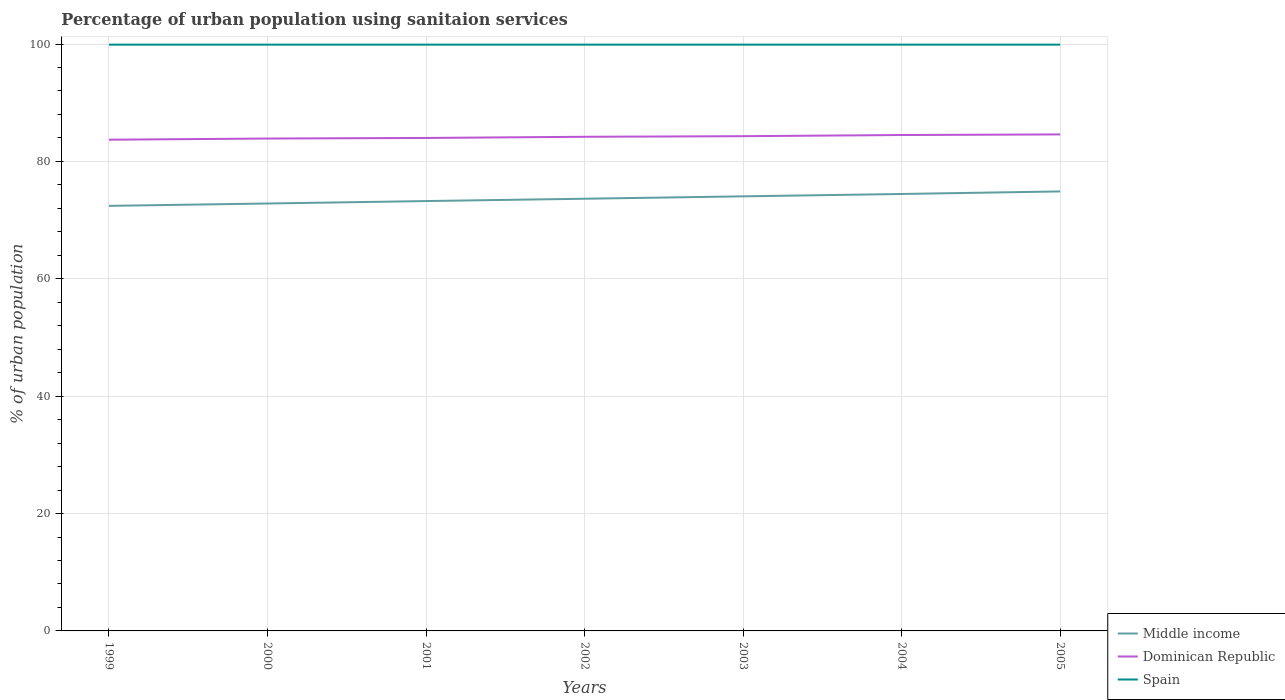Across all years, what is the maximum percentage of urban population using sanitaion services in Middle income?
Keep it short and to the point. 72.43. What is the total percentage of urban population using sanitaion services in Dominican Republic in the graph?
Ensure brevity in your answer.  -0.8. What is the difference between the highest and the lowest percentage of urban population using sanitaion services in Dominican Republic?
Your response must be concise. 4. Is the percentage of urban population using sanitaion services in Spain strictly greater than the percentage of urban population using sanitaion services in Dominican Republic over the years?
Your answer should be very brief. No. How many years are there in the graph?
Provide a succinct answer. 7. Does the graph contain grids?
Give a very brief answer. Yes. How are the legend labels stacked?
Your answer should be very brief. Vertical. What is the title of the graph?
Give a very brief answer. Percentage of urban population using sanitaion services. Does "Andorra" appear as one of the legend labels in the graph?
Your answer should be very brief. No. What is the label or title of the Y-axis?
Ensure brevity in your answer.  % of urban population. What is the % of urban population of Middle income in 1999?
Provide a succinct answer. 72.43. What is the % of urban population of Dominican Republic in 1999?
Keep it short and to the point. 83.7. What is the % of urban population in Spain in 1999?
Provide a succinct answer. 99.9. What is the % of urban population of Middle income in 2000?
Make the answer very short. 72.83. What is the % of urban population of Dominican Republic in 2000?
Provide a short and direct response. 83.9. What is the % of urban population in Spain in 2000?
Offer a very short reply. 99.9. What is the % of urban population in Middle income in 2001?
Offer a very short reply. 73.25. What is the % of urban population in Spain in 2001?
Make the answer very short. 99.9. What is the % of urban population of Middle income in 2002?
Your answer should be compact. 73.64. What is the % of urban population of Dominican Republic in 2002?
Your response must be concise. 84.2. What is the % of urban population of Spain in 2002?
Provide a succinct answer. 99.9. What is the % of urban population in Middle income in 2003?
Keep it short and to the point. 74.05. What is the % of urban population of Dominican Republic in 2003?
Offer a very short reply. 84.3. What is the % of urban population of Spain in 2003?
Offer a very short reply. 99.9. What is the % of urban population of Middle income in 2004?
Your answer should be very brief. 74.45. What is the % of urban population of Dominican Republic in 2004?
Offer a very short reply. 84.5. What is the % of urban population in Spain in 2004?
Offer a very short reply. 99.9. What is the % of urban population in Middle income in 2005?
Provide a short and direct response. 74.89. What is the % of urban population of Dominican Republic in 2005?
Give a very brief answer. 84.6. What is the % of urban population of Spain in 2005?
Give a very brief answer. 99.9. Across all years, what is the maximum % of urban population in Middle income?
Provide a succinct answer. 74.89. Across all years, what is the maximum % of urban population in Dominican Republic?
Make the answer very short. 84.6. Across all years, what is the maximum % of urban population of Spain?
Your answer should be compact. 99.9. Across all years, what is the minimum % of urban population of Middle income?
Keep it short and to the point. 72.43. Across all years, what is the minimum % of urban population of Dominican Republic?
Your answer should be compact. 83.7. Across all years, what is the minimum % of urban population in Spain?
Keep it short and to the point. 99.9. What is the total % of urban population of Middle income in the graph?
Keep it short and to the point. 515.54. What is the total % of urban population of Dominican Republic in the graph?
Your answer should be compact. 589.2. What is the total % of urban population of Spain in the graph?
Provide a short and direct response. 699.3. What is the difference between the % of urban population in Middle income in 1999 and that in 2000?
Ensure brevity in your answer.  -0.4. What is the difference between the % of urban population in Dominican Republic in 1999 and that in 2000?
Your answer should be compact. -0.2. What is the difference between the % of urban population of Middle income in 1999 and that in 2001?
Your answer should be very brief. -0.82. What is the difference between the % of urban population of Dominican Republic in 1999 and that in 2001?
Keep it short and to the point. -0.3. What is the difference between the % of urban population of Middle income in 1999 and that in 2002?
Keep it short and to the point. -1.22. What is the difference between the % of urban population of Spain in 1999 and that in 2002?
Your response must be concise. 0. What is the difference between the % of urban population in Middle income in 1999 and that in 2003?
Offer a terse response. -1.62. What is the difference between the % of urban population of Dominican Republic in 1999 and that in 2003?
Give a very brief answer. -0.6. What is the difference between the % of urban population of Middle income in 1999 and that in 2004?
Your answer should be compact. -2.02. What is the difference between the % of urban population of Dominican Republic in 1999 and that in 2004?
Provide a succinct answer. -0.8. What is the difference between the % of urban population in Middle income in 1999 and that in 2005?
Offer a very short reply. -2.46. What is the difference between the % of urban population of Middle income in 2000 and that in 2001?
Your answer should be very brief. -0.42. What is the difference between the % of urban population of Middle income in 2000 and that in 2002?
Offer a terse response. -0.81. What is the difference between the % of urban population in Dominican Republic in 2000 and that in 2002?
Your answer should be very brief. -0.3. What is the difference between the % of urban population of Middle income in 2000 and that in 2003?
Your response must be concise. -1.22. What is the difference between the % of urban population of Dominican Republic in 2000 and that in 2003?
Give a very brief answer. -0.4. What is the difference between the % of urban population in Spain in 2000 and that in 2003?
Provide a succinct answer. 0. What is the difference between the % of urban population in Middle income in 2000 and that in 2004?
Offer a terse response. -1.62. What is the difference between the % of urban population of Dominican Republic in 2000 and that in 2004?
Give a very brief answer. -0.6. What is the difference between the % of urban population in Middle income in 2000 and that in 2005?
Your response must be concise. -2.06. What is the difference between the % of urban population in Dominican Republic in 2000 and that in 2005?
Provide a succinct answer. -0.7. What is the difference between the % of urban population of Middle income in 2001 and that in 2002?
Offer a terse response. -0.4. What is the difference between the % of urban population in Spain in 2001 and that in 2002?
Offer a terse response. 0. What is the difference between the % of urban population in Middle income in 2001 and that in 2003?
Give a very brief answer. -0.8. What is the difference between the % of urban population of Middle income in 2001 and that in 2004?
Make the answer very short. -1.21. What is the difference between the % of urban population of Middle income in 2001 and that in 2005?
Provide a short and direct response. -1.64. What is the difference between the % of urban population in Middle income in 2002 and that in 2003?
Offer a very short reply. -0.41. What is the difference between the % of urban population in Spain in 2002 and that in 2003?
Offer a terse response. 0. What is the difference between the % of urban population in Middle income in 2002 and that in 2004?
Provide a short and direct response. -0.81. What is the difference between the % of urban population of Middle income in 2002 and that in 2005?
Provide a short and direct response. -1.25. What is the difference between the % of urban population in Middle income in 2003 and that in 2004?
Provide a succinct answer. -0.4. What is the difference between the % of urban population of Dominican Republic in 2003 and that in 2004?
Offer a very short reply. -0.2. What is the difference between the % of urban population in Spain in 2003 and that in 2004?
Your response must be concise. 0. What is the difference between the % of urban population in Middle income in 2003 and that in 2005?
Offer a very short reply. -0.84. What is the difference between the % of urban population of Dominican Republic in 2003 and that in 2005?
Keep it short and to the point. -0.3. What is the difference between the % of urban population in Spain in 2003 and that in 2005?
Give a very brief answer. 0. What is the difference between the % of urban population in Middle income in 2004 and that in 2005?
Your response must be concise. -0.44. What is the difference between the % of urban population of Middle income in 1999 and the % of urban population of Dominican Republic in 2000?
Your answer should be very brief. -11.47. What is the difference between the % of urban population in Middle income in 1999 and the % of urban population in Spain in 2000?
Provide a short and direct response. -27.47. What is the difference between the % of urban population in Dominican Republic in 1999 and the % of urban population in Spain in 2000?
Provide a succinct answer. -16.2. What is the difference between the % of urban population in Middle income in 1999 and the % of urban population in Dominican Republic in 2001?
Your answer should be very brief. -11.57. What is the difference between the % of urban population of Middle income in 1999 and the % of urban population of Spain in 2001?
Make the answer very short. -27.47. What is the difference between the % of urban population of Dominican Republic in 1999 and the % of urban population of Spain in 2001?
Give a very brief answer. -16.2. What is the difference between the % of urban population in Middle income in 1999 and the % of urban population in Dominican Republic in 2002?
Ensure brevity in your answer.  -11.77. What is the difference between the % of urban population in Middle income in 1999 and the % of urban population in Spain in 2002?
Provide a succinct answer. -27.47. What is the difference between the % of urban population in Dominican Republic in 1999 and the % of urban population in Spain in 2002?
Provide a succinct answer. -16.2. What is the difference between the % of urban population in Middle income in 1999 and the % of urban population in Dominican Republic in 2003?
Make the answer very short. -11.87. What is the difference between the % of urban population of Middle income in 1999 and the % of urban population of Spain in 2003?
Offer a terse response. -27.47. What is the difference between the % of urban population of Dominican Republic in 1999 and the % of urban population of Spain in 2003?
Provide a succinct answer. -16.2. What is the difference between the % of urban population of Middle income in 1999 and the % of urban population of Dominican Republic in 2004?
Offer a very short reply. -12.07. What is the difference between the % of urban population of Middle income in 1999 and the % of urban population of Spain in 2004?
Offer a terse response. -27.47. What is the difference between the % of urban population of Dominican Republic in 1999 and the % of urban population of Spain in 2004?
Provide a succinct answer. -16.2. What is the difference between the % of urban population in Middle income in 1999 and the % of urban population in Dominican Republic in 2005?
Provide a short and direct response. -12.17. What is the difference between the % of urban population of Middle income in 1999 and the % of urban population of Spain in 2005?
Your response must be concise. -27.47. What is the difference between the % of urban population in Dominican Republic in 1999 and the % of urban population in Spain in 2005?
Offer a very short reply. -16.2. What is the difference between the % of urban population of Middle income in 2000 and the % of urban population of Dominican Republic in 2001?
Your answer should be very brief. -11.17. What is the difference between the % of urban population in Middle income in 2000 and the % of urban population in Spain in 2001?
Provide a short and direct response. -27.07. What is the difference between the % of urban population of Middle income in 2000 and the % of urban population of Dominican Republic in 2002?
Provide a succinct answer. -11.37. What is the difference between the % of urban population in Middle income in 2000 and the % of urban population in Spain in 2002?
Provide a succinct answer. -27.07. What is the difference between the % of urban population in Dominican Republic in 2000 and the % of urban population in Spain in 2002?
Your response must be concise. -16. What is the difference between the % of urban population in Middle income in 2000 and the % of urban population in Dominican Republic in 2003?
Offer a very short reply. -11.47. What is the difference between the % of urban population in Middle income in 2000 and the % of urban population in Spain in 2003?
Ensure brevity in your answer.  -27.07. What is the difference between the % of urban population of Dominican Republic in 2000 and the % of urban population of Spain in 2003?
Provide a short and direct response. -16. What is the difference between the % of urban population in Middle income in 2000 and the % of urban population in Dominican Republic in 2004?
Keep it short and to the point. -11.67. What is the difference between the % of urban population of Middle income in 2000 and the % of urban population of Spain in 2004?
Make the answer very short. -27.07. What is the difference between the % of urban population in Dominican Republic in 2000 and the % of urban population in Spain in 2004?
Your answer should be compact. -16. What is the difference between the % of urban population in Middle income in 2000 and the % of urban population in Dominican Republic in 2005?
Your answer should be very brief. -11.77. What is the difference between the % of urban population of Middle income in 2000 and the % of urban population of Spain in 2005?
Ensure brevity in your answer.  -27.07. What is the difference between the % of urban population of Middle income in 2001 and the % of urban population of Dominican Republic in 2002?
Keep it short and to the point. -10.95. What is the difference between the % of urban population in Middle income in 2001 and the % of urban population in Spain in 2002?
Make the answer very short. -26.65. What is the difference between the % of urban population in Dominican Republic in 2001 and the % of urban population in Spain in 2002?
Offer a very short reply. -15.9. What is the difference between the % of urban population in Middle income in 2001 and the % of urban population in Dominican Republic in 2003?
Offer a very short reply. -11.05. What is the difference between the % of urban population of Middle income in 2001 and the % of urban population of Spain in 2003?
Provide a succinct answer. -26.65. What is the difference between the % of urban population in Dominican Republic in 2001 and the % of urban population in Spain in 2003?
Offer a terse response. -15.9. What is the difference between the % of urban population of Middle income in 2001 and the % of urban population of Dominican Republic in 2004?
Ensure brevity in your answer.  -11.25. What is the difference between the % of urban population of Middle income in 2001 and the % of urban population of Spain in 2004?
Offer a terse response. -26.65. What is the difference between the % of urban population of Dominican Republic in 2001 and the % of urban population of Spain in 2004?
Make the answer very short. -15.9. What is the difference between the % of urban population of Middle income in 2001 and the % of urban population of Dominican Republic in 2005?
Ensure brevity in your answer.  -11.35. What is the difference between the % of urban population of Middle income in 2001 and the % of urban population of Spain in 2005?
Give a very brief answer. -26.65. What is the difference between the % of urban population of Dominican Republic in 2001 and the % of urban population of Spain in 2005?
Keep it short and to the point. -15.9. What is the difference between the % of urban population of Middle income in 2002 and the % of urban population of Dominican Republic in 2003?
Ensure brevity in your answer.  -10.66. What is the difference between the % of urban population in Middle income in 2002 and the % of urban population in Spain in 2003?
Your answer should be compact. -26.26. What is the difference between the % of urban population of Dominican Republic in 2002 and the % of urban population of Spain in 2003?
Keep it short and to the point. -15.7. What is the difference between the % of urban population of Middle income in 2002 and the % of urban population of Dominican Republic in 2004?
Provide a succinct answer. -10.86. What is the difference between the % of urban population in Middle income in 2002 and the % of urban population in Spain in 2004?
Keep it short and to the point. -26.26. What is the difference between the % of urban population of Dominican Republic in 2002 and the % of urban population of Spain in 2004?
Offer a very short reply. -15.7. What is the difference between the % of urban population in Middle income in 2002 and the % of urban population in Dominican Republic in 2005?
Offer a very short reply. -10.96. What is the difference between the % of urban population of Middle income in 2002 and the % of urban population of Spain in 2005?
Provide a short and direct response. -26.26. What is the difference between the % of urban population in Dominican Republic in 2002 and the % of urban population in Spain in 2005?
Ensure brevity in your answer.  -15.7. What is the difference between the % of urban population in Middle income in 2003 and the % of urban population in Dominican Republic in 2004?
Give a very brief answer. -10.45. What is the difference between the % of urban population of Middle income in 2003 and the % of urban population of Spain in 2004?
Offer a very short reply. -25.85. What is the difference between the % of urban population of Dominican Republic in 2003 and the % of urban population of Spain in 2004?
Keep it short and to the point. -15.6. What is the difference between the % of urban population of Middle income in 2003 and the % of urban population of Dominican Republic in 2005?
Offer a very short reply. -10.55. What is the difference between the % of urban population of Middle income in 2003 and the % of urban population of Spain in 2005?
Make the answer very short. -25.85. What is the difference between the % of urban population in Dominican Republic in 2003 and the % of urban population in Spain in 2005?
Give a very brief answer. -15.6. What is the difference between the % of urban population of Middle income in 2004 and the % of urban population of Dominican Republic in 2005?
Your answer should be compact. -10.15. What is the difference between the % of urban population in Middle income in 2004 and the % of urban population in Spain in 2005?
Provide a short and direct response. -25.45. What is the difference between the % of urban population in Dominican Republic in 2004 and the % of urban population in Spain in 2005?
Provide a short and direct response. -15.4. What is the average % of urban population in Middle income per year?
Give a very brief answer. 73.65. What is the average % of urban population of Dominican Republic per year?
Offer a very short reply. 84.17. What is the average % of urban population in Spain per year?
Your answer should be very brief. 99.9. In the year 1999, what is the difference between the % of urban population of Middle income and % of urban population of Dominican Republic?
Give a very brief answer. -11.27. In the year 1999, what is the difference between the % of urban population of Middle income and % of urban population of Spain?
Give a very brief answer. -27.47. In the year 1999, what is the difference between the % of urban population in Dominican Republic and % of urban population in Spain?
Make the answer very short. -16.2. In the year 2000, what is the difference between the % of urban population in Middle income and % of urban population in Dominican Republic?
Offer a very short reply. -11.07. In the year 2000, what is the difference between the % of urban population of Middle income and % of urban population of Spain?
Your response must be concise. -27.07. In the year 2001, what is the difference between the % of urban population in Middle income and % of urban population in Dominican Republic?
Ensure brevity in your answer.  -10.75. In the year 2001, what is the difference between the % of urban population in Middle income and % of urban population in Spain?
Keep it short and to the point. -26.65. In the year 2001, what is the difference between the % of urban population of Dominican Republic and % of urban population of Spain?
Your answer should be very brief. -15.9. In the year 2002, what is the difference between the % of urban population in Middle income and % of urban population in Dominican Republic?
Give a very brief answer. -10.56. In the year 2002, what is the difference between the % of urban population of Middle income and % of urban population of Spain?
Provide a succinct answer. -26.26. In the year 2002, what is the difference between the % of urban population of Dominican Republic and % of urban population of Spain?
Ensure brevity in your answer.  -15.7. In the year 2003, what is the difference between the % of urban population in Middle income and % of urban population in Dominican Republic?
Give a very brief answer. -10.25. In the year 2003, what is the difference between the % of urban population of Middle income and % of urban population of Spain?
Give a very brief answer. -25.85. In the year 2003, what is the difference between the % of urban population of Dominican Republic and % of urban population of Spain?
Your response must be concise. -15.6. In the year 2004, what is the difference between the % of urban population in Middle income and % of urban population in Dominican Republic?
Keep it short and to the point. -10.05. In the year 2004, what is the difference between the % of urban population in Middle income and % of urban population in Spain?
Your answer should be compact. -25.45. In the year 2004, what is the difference between the % of urban population in Dominican Republic and % of urban population in Spain?
Keep it short and to the point. -15.4. In the year 2005, what is the difference between the % of urban population in Middle income and % of urban population in Dominican Republic?
Offer a terse response. -9.71. In the year 2005, what is the difference between the % of urban population of Middle income and % of urban population of Spain?
Offer a very short reply. -25.01. In the year 2005, what is the difference between the % of urban population of Dominican Republic and % of urban population of Spain?
Offer a very short reply. -15.3. What is the ratio of the % of urban population in Middle income in 1999 to that in 2000?
Provide a succinct answer. 0.99. What is the ratio of the % of urban population in Dominican Republic in 1999 to that in 2000?
Your answer should be compact. 1. What is the ratio of the % of urban population in Middle income in 1999 to that in 2001?
Your response must be concise. 0.99. What is the ratio of the % of urban population of Dominican Republic in 1999 to that in 2001?
Keep it short and to the point. 1. What is the ratio of the % of urban population in Middle income in 1999 to that in 2002?
Keep it short and to the point. 0.98. What is the ratio of the % of urban population in Middle income in 1999 to that in 2003?
Offer a very short reply. 0.98. What is the ratio of the % of urban population of Middle income in 1999 to that in 2004?
Your response must be concise. 0.97. What is the ratio of the % of urban population in Dominican Republic in 1999 to that in 2004?
Make the answer very short. 0.99. What is the ratio of the % of urban population in Middle income in 1999 to that in 2005?
Offer a terse response. 0.97. What is the ratio of the % of urban population in Spain in 1999 to that in 2005?
Offer a terse response. 1. What is the ratio of the % of urban population of Spain in 2000 to that in 2001?
Provide a short and direct response. 1. What is the ratio of the % of urban population of Dominican Republic in 2000 to that in 2002?
Provide a short and direct response. 1. What is the ratio of the % of urban population in Spain in 2000 to that in 2002?
Make the answer very short. 1. What is the ratio of the % of urban population of Middle income in 2000 to that in 2003?
Offer a terse response. 0.98. What is the ratio of the % of urban population in Middle income in 2000 to that in 2004?
Your answer should be compact. 0.98. What is the ratio of the % of urban population of Dominican Republic in 2000 to that in 2004?
Your answer should be compact. 0.99. What is the ratio of the % of urban population in Middle income in 2000 to that in 2005?
Ensure brevity in your answer.  0.97. What is the ratio of the % of urban population in Spain in 2000 to that in 2005?
Provide a short and direct response. 1. What is the ratio of the % of urban population of Middle income in 2001 to that in 2002?
Keep it short and to the point. 0.99. What is the ratio of the % of urban population of Middle income in 2001 to that in 2003?
Ensure brevity in your answer.  0.99. What is the ratio of the % of urban population in Dominican Republic in 2001 to that in 2003?
Ensure brevity in your answer.  1. What is the ratio of the % of urban population of Middle income in 2001 to that in 2004?
Ensure brevity in your answer.  0.98. What is the ratio of the % of urban population of Spain in 2001 to that in 2004?
Ensure brevity in your answer.  1. What is the ratio of the % of urban population in Middle income in 2001 to that in 2005?
Your response must be concise. 0.98. What is the ratio of the % of urban population of Dominican Republic in 2001 to that in 2005?
Your response must be concise. 0.99. What is the ratio of the % of urban population in Spain in 2001 to that in 2005?
Provide a succinct answer. 1. What is the ratio of the % of urban population of Middle income in 2002 to that in 2003?
Make the answer very short. 0.99. What is the ratio of the % of urban population of Dominican Republic in 2002 to that in 2003?
Make the answer very short. 1. What is the ratio of the % of urban population in Spain in 2002 to that in 2003?
Offer a terse response. 1. What is the ratio of the % of urban population of Middle income in 2002 to that in 2004?
Ensure brevity in your answer.  0.99. What is the ratio of the % of urban population in Middle income in 2002 to that in 2005?
Your response must be concise. 0.98. What is the ratio of the % of urban population of Spain in 2002 to that in 2005?
Provide a short and direct response. 1. What is the ratio of the % of urban population in Middle income in 2003 to that in 2004?
Give a very brief answer. 0.99. What is the ratio of the % of urban population in Spain in 2003 to that in 2004?
Your response must be concise. 1. What is the ratio of the % of urban population in Dominican Republic in 2003 to that in 2005?
Offer a terse response. 1. What is the ratio of the % of urban population in Spain in 2004 to that in 2005?
Ensure brevity in your answer.  1. What is the difference between the highest and the second highest % of urban population of Middle income?
Your response must be concise. 0.44. What is the difference between the highest and the second highest % of urban population of Spain?
Give a very brief answer. 0. What is the difference between the highest and the lowest % of urban population of Middle income?
Your answer should be compact. 2.46. What is the difference between the highest and the lowest % of urban population of Spain?
Offer a very short reply. 0. 